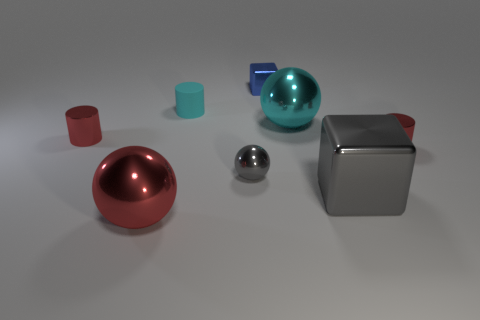Add 1 gray things. How many objects exist? 9 Subtract all spheres. How many objects are left? 5 Add 1 big metal things. How many big metal things exist? 4 Subtract 1 red cylinders. How many objects are left? 7 Subtract all small cyan rubber cubes. Subtract all big gray cubes. How many objects are left? 7 Add 1 big balls. How many big balls are left? 3 